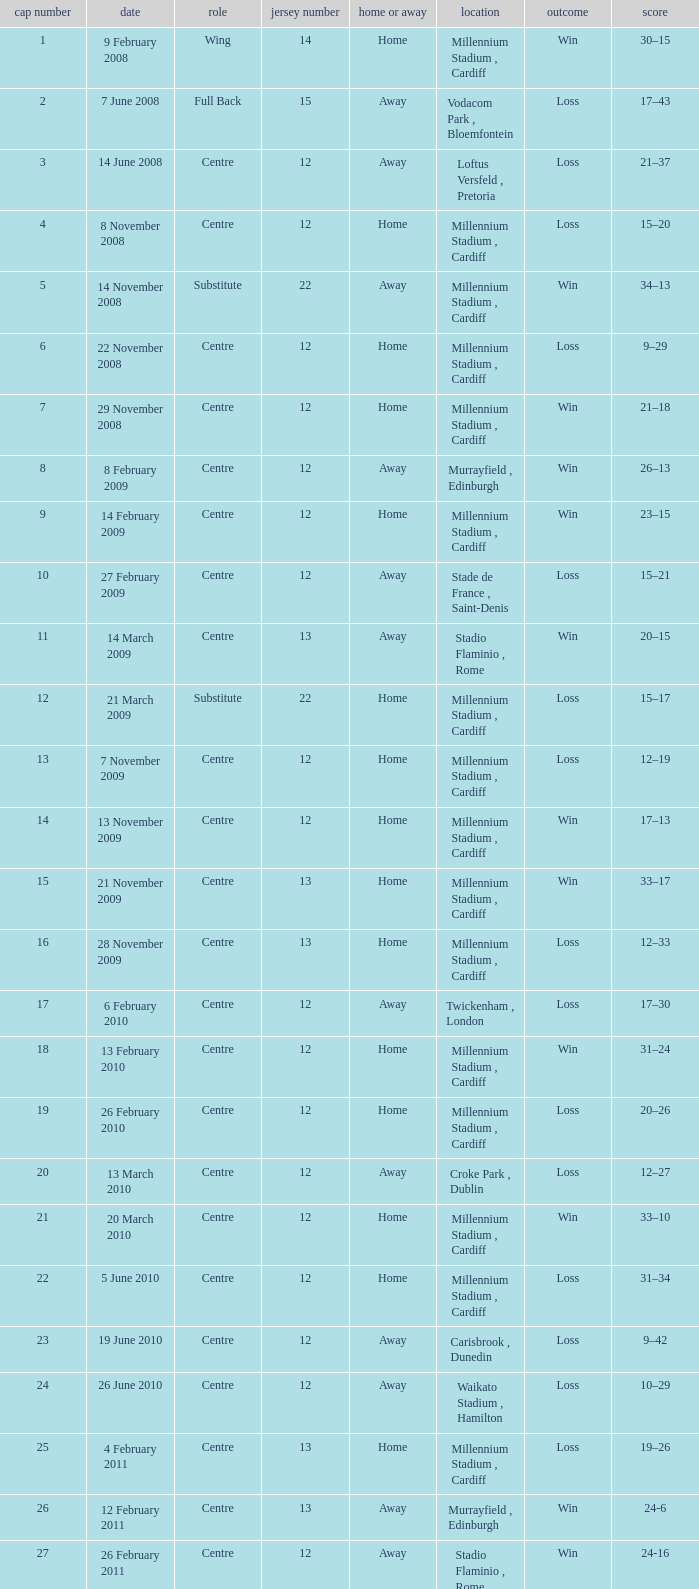What's the largest shirt number when the cap number is 5? 22.0. Write the full table. {'header': ['cap number', 'date', 'role', 'jersey number', 'home or away', 'location', 'outcome', 'score'], 'rows': [['1', '9 February 2008', 'Wing', '14', 'Home', 'Millennium Stadium , Cardiff', 'Win', '30–15'], ['2', '7 June 2008', 'Full Back', '15', 'Away', 'Vodacom Park , Bloemfontein', 'Loss', '17–43'], ['3', '14 June 2008', 'Centre', '12', 'Away', 'Loftus Versfeld , Pretoria', 'Loss', '21–37'], ['4', '8 November 2008', 'Centre', '12', 'Home', 'Millennium Stadium , Cardiff', 'Loss', '15–20'], ['5', '14 November 2008', 'Substitute', '22', 'Away', 'Millennium Stadium , Cardiff', 'Win', '34–13'], ['6', '22 November 2008', 'Centre', '12', 'Home', 'Millennium Stadium , Cardiff', 'Loss', '9–29'], ['7', '29 November 2008', 'Centre', '12', 'Home', 'Millennium Stadium , Cardiff', 'Win', '21–18'], ['8', '8 February 2009', 'Centre', '12', 'Away', 'Murrayfield , Edinburgh', 'Win', '26–13'], ['9', '14 February 2009', 'Centre', '12', 'Home', 'Millennium Stadium , Cardiff', 'Win', '23–15'], ['10', '27 February 2009', 'Centre', '12', 'Away', 'Stade de France , Saint-Denis', 'Loss', '15–21'], ['11', '14 March 2009', 'Centre', '13', 'Away', 'Stadio Flaminio , Rome', 'Win', '20–15'], ['12', '21 March 2009', 'Substitute', '22', 'Home', 'Millennium Stadium , Cardiff', 'Loss', '15–17'], ['13', '7 November 2009', 'Centre', '12', 'Home', 'Millennium Stadium , Cardiff', 'Loss', '12–19'], ['14', '13 November 2009', 'Centre', '12', 'Home', 'Millennium Stadium , Cardiff', 'Win', '17–13'], ['15', '21 November 2009', 'Centre', '13', 'Home', 'Millennium Stadium , Cardiff', 'Win', '33–17'], ['16', '28 November 2009', 'Centre', '13', 'Home', 'Millennium Stadium , Cardiff', 'Loss', '12–33'], ['17', '6 February 2010', 'Centre', '12', 'Away', 'Twickenham , London', 'Loss', '17–30'], ['18', '13 February 2010', 'Centre', '12', 'Home', 'Millennium Stadium , Cardiff', 'Win', '31–24'], ['19', '26 February 2010', 'Centre', '12', 'Home', 'Millennium Stadium , Cardiff', 'Loss', '20–26'], ['20', '13 March 2010', 'Centre', '12', 'Away', 'Croke Park , Dublin', 'Loss', '12–27'], ['21', '20 March 2010', 'Centre', '12', 'Home', 'Millennium Stadium , Cardiff', 'Win', '33–10'], ['22', '5 June 2010', 'Centre', '12', 'Home', 'Millennium Stadium , Cardiff', 'Loss', '31–34'], ['23', '19 June 2010', 'Centre', '12', 'Away', 'Carisbrook , Dunedin', 'Loss', '9–42'], ['24', '26 June 2010', 'Centre', '12', 'Away', 'Waikato Stadium , Hamilton', 'Loss', '10–29'], ['25', '4 February 2011', 'Centre', '13', 'Home', 'Millennium Stadium , Cardiff', 'Loss', '19–26'], ['26', '12 February 2011', 'Centre', '13', 'Away', 'Murrayfield , Edinburgh', 'Win', '24-6'], ['27', '26 February 2011', 'Centre', '12', 'Away', 'Stadio Flaminio , Rome', 'Win', '24-16'], ['28', '12 March 2011', 'Centre', '13', 'Home', 'Millennium Stadium , Cardiff', 'Win', '19-13'], ['29', '19 March 2011', 'Centre', '13', 'Away', 'Stade de France , Saint-Denis', 'Loss', '9-28'], ['30', '6 August 2011', 'Centre', '12', 'Away', 'Twickenham , London', 'Loss', '19-23'], ['31', '13 August 2011', 'Centre', '13', 'Home', 'Millennium Stadium , Cardiff', 'Win', '19-9'], ['32', '20 August 2011', 'Centre', '12', 'Home', 'Millennium Stadium , Cardiff', 'Win', '28-13'], ['33', '11 September 2011', 'Centre', '12', 'Rugby World Cup', 'Westpac Stadium , Wellington', 'Loss', '16-17'], ['34', '18 September 2011', 'Centre', '12', 'Rugby World Cup', 'Waikato Stadium , Hamilton', 'Win', '17-10'], ['35', '2 September 2011', 'Centre', '12', 'Rugby World Cup', 'Waikato Stadium , Hamilton', 'Win', '66-0'], ['36', '8 October 2011', 'Centre', '12', 'Rugby World Cup', 'Westpac Stadium , Wellington', 'Win', '22-10'], ['37', '15 October 2011', 'Centre', '12', 'Rugby World Cup', 'Eden Park , Auckland', 'Loss', '8-9'], ['38', '21 October 2011', 'Centre', '12', 'Rugby World Cup', 'Eden Park , Auckland', 'Loss', '18-21'], ['39', '3 December 2011', 'Centre', '12', 'Home', 'Millennium Stadium , Cardiff', 'Loss', '18-24'], ['40', '5 February 2012', 'Centre', '12', 'Away', 'Aviva Stadium , Dublin', 'Win', '23-21'], ['41', '12 February 2012', 'Centre', '12', 'Home', 'Millennium Stadium , Cardiff', 'Win', '27-13'], ['42', '25 February 2012', 'Centre', '12', 'Away', 'Twickenham , London', 'Win', '19-12'], ['43', '9 March 2012', 'Centre', '12', 'Home', 'Millennium Stadium , Cardiff', 'Win', '24-3'], ['44', '16 March 2012', 'Centre', '12', 'Home', 'Millennium Stadium , Cardiff', 'Win', '16-9'], ['45', '10 November 2012', 'Centre', '12', 'Home', 'Millennium Stadium , Cardiff', 'Loss', '12-26'], ['46', '16 November 2012', 'Centre', '12', 'Home', 'Millennium Stadium , Cardiff', 'Loss', '19-26'], ['47', '24 November 2012', 'Centre', '12', 'Home', 'Millennium Stadium , Cardiff', 'Loss', '10-33'], ['48', '1 December 2012', 'Centre', '12', 'Home', 'Millennium Stadium , Cardiff', 'Loss', '12-14'], ['49', '2 February', 'Centre', '12', 'Home', 'Millennium Stadium , Cardiff', 'Loss', '22-30'], ['50', '9 February', 'Centre', '12', 'Home', 'Stade de France , Paris', 'Win', '16-6']]} 